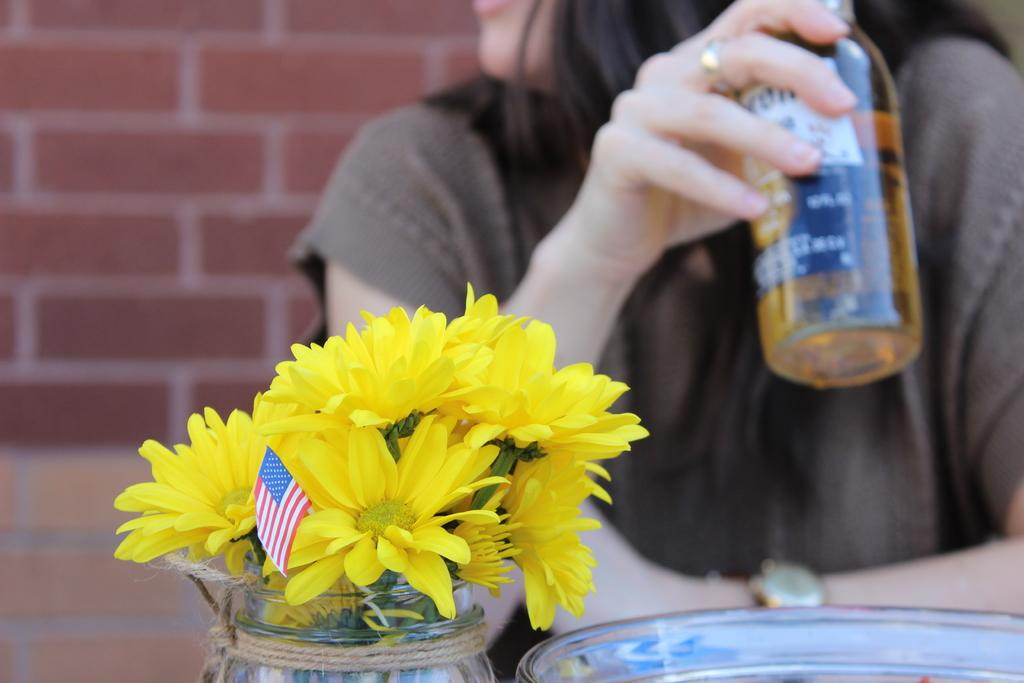Who or what is present in the image? There is a person in the image. What is the person holding? The person is holding a bottle. What other objects can be seen in the image? There is a flower vase and a flag in the image. What is visible in the background of the image? There is a wall in the background of the image. What type of mask is the person wearing in the image? There is no mask present in the image; the person is holding a bottle. How many feet can be seen in the image? There is no foot visible in the image; it features a person holding a bottle, a flower vase, and a flag, with a wall in the background. 